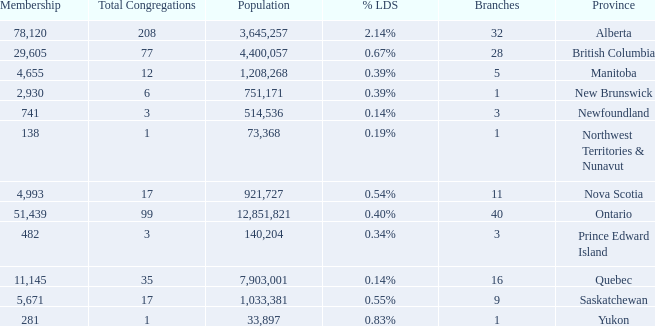What's the sum of the total congregation in the manitoba province with less than 1,208,268 population? None. 